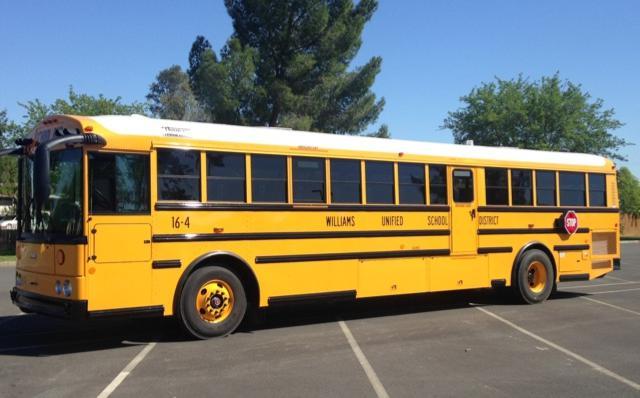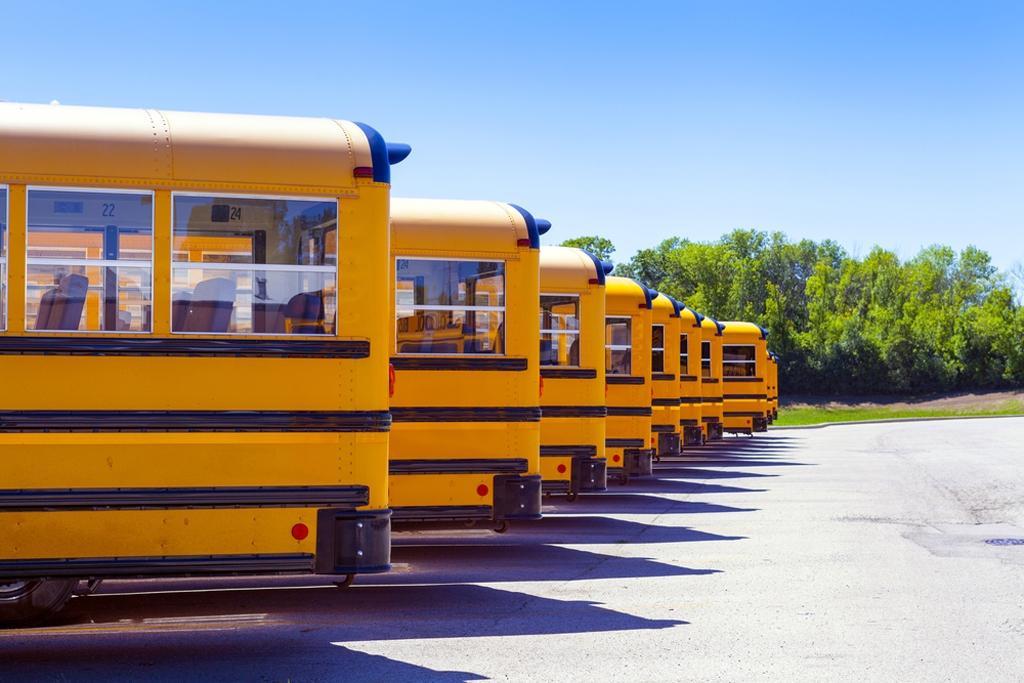The first image is the image on the left, the second image is the image on the right. Assess this claim about the two images: "The left image features one flat-fronted bus parked at an angle in a parking lot, and the right image features a row of parked buses forming a diagonal line.". Correct or not? Answer yes or no. Yes. 